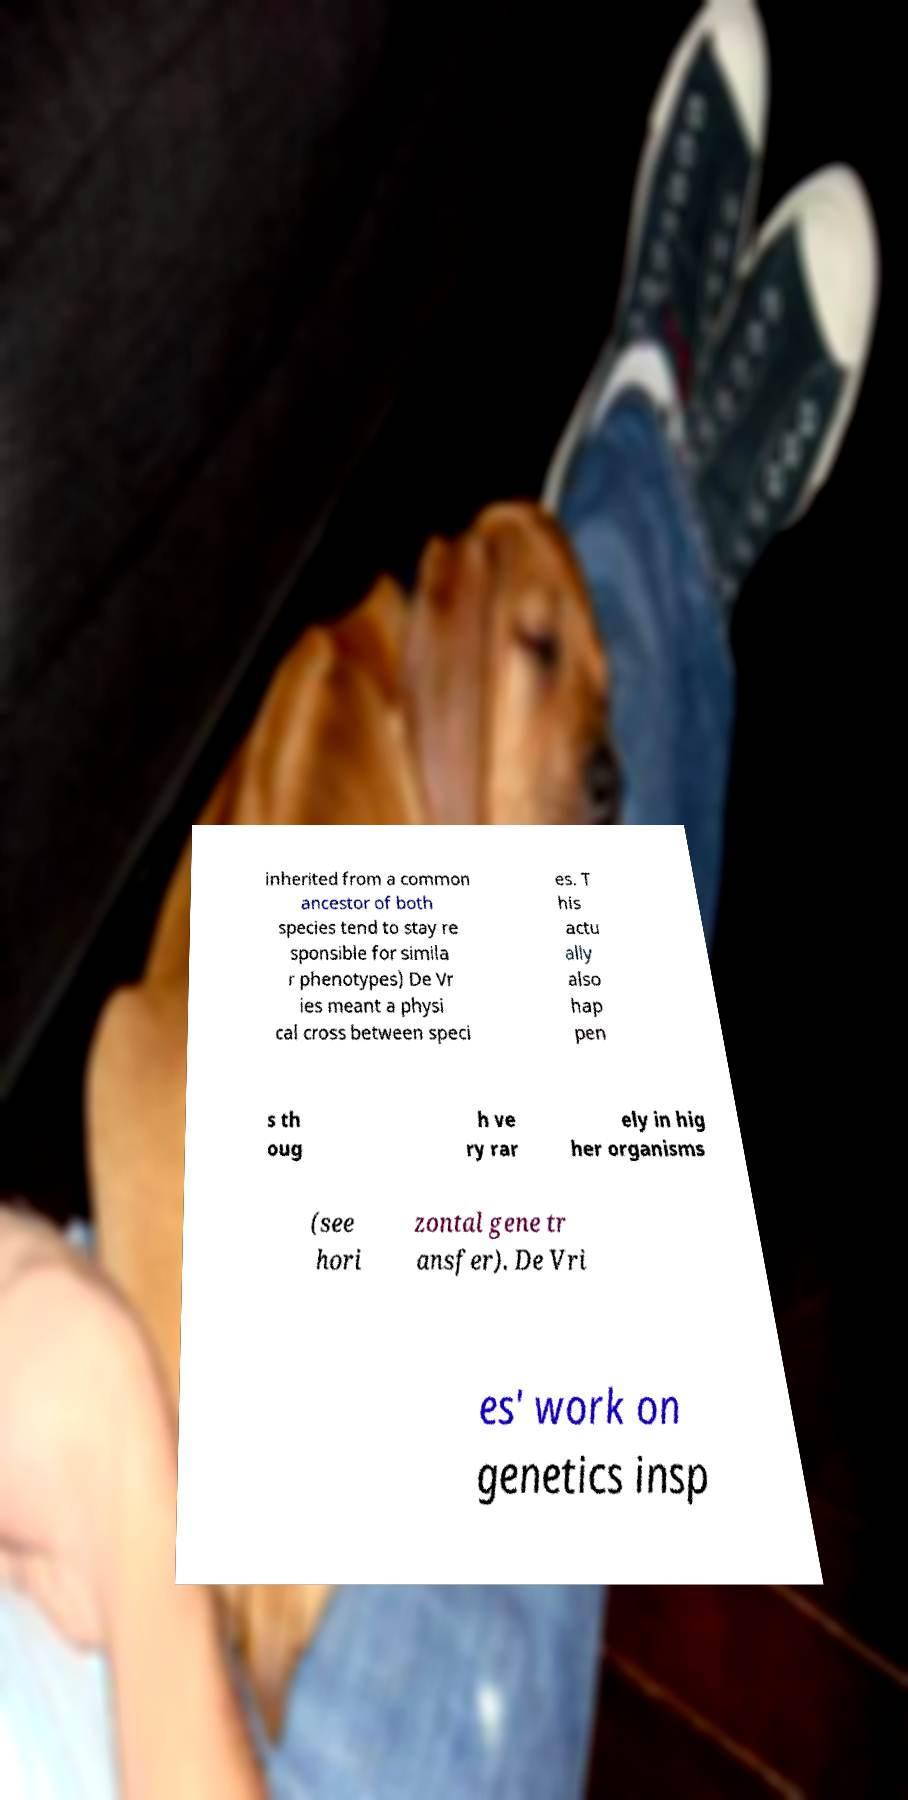Can you read and provide the text displayed in the image?This photo seems to have some interesting text. Can you extract and type it out for me? inherited from a common ancestor of both species tend to stay re sponsible for simila r phenotypes) De Vr ies meant a physi cal cross between speci es. T his actu ally also hap pen s th oug h ve ry rar ely in hig her organisms (see hori zontal gene tr ansfer). De Vri es' work on genetics insp 